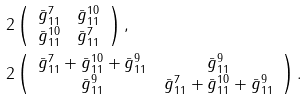Convert formula to latex. <formula><loc_0><loc_0><loc_500><loc_500>& 2 \left ( \begin{array} { c c } \bar { g } _ { 1 1 } ^ { 7 } & \bar { g } _ { 1 1 } ^ { 1 0 } \\ \bar { g } _ { 1 1 } ^ { 1 0 } & \bar { g } _ { 1 1 } ^ { 7 } \end{array} \right ) , \\ & 2 \left ( \begin{array} { c c } \bar { g } _ { 1 1 } ^ { 7 } + \bar { g } _ { 1 1 } ^ { 1 0 } + \bar { g } _ { 1 1 } ^ { 9 } & \bar { g } _ { 1 1 } ^ { 9 } \\ \bar { g } _ { 1 1 } ^ { 9 } & \bar { g } _ { 1 1 } ^ { 7 } + \bar { g } _ { 1 1 } ^ { 1 0 } + \bar { g } _ { 1 1 } ^ { 9 } \end{array} \right ) .</formula> 